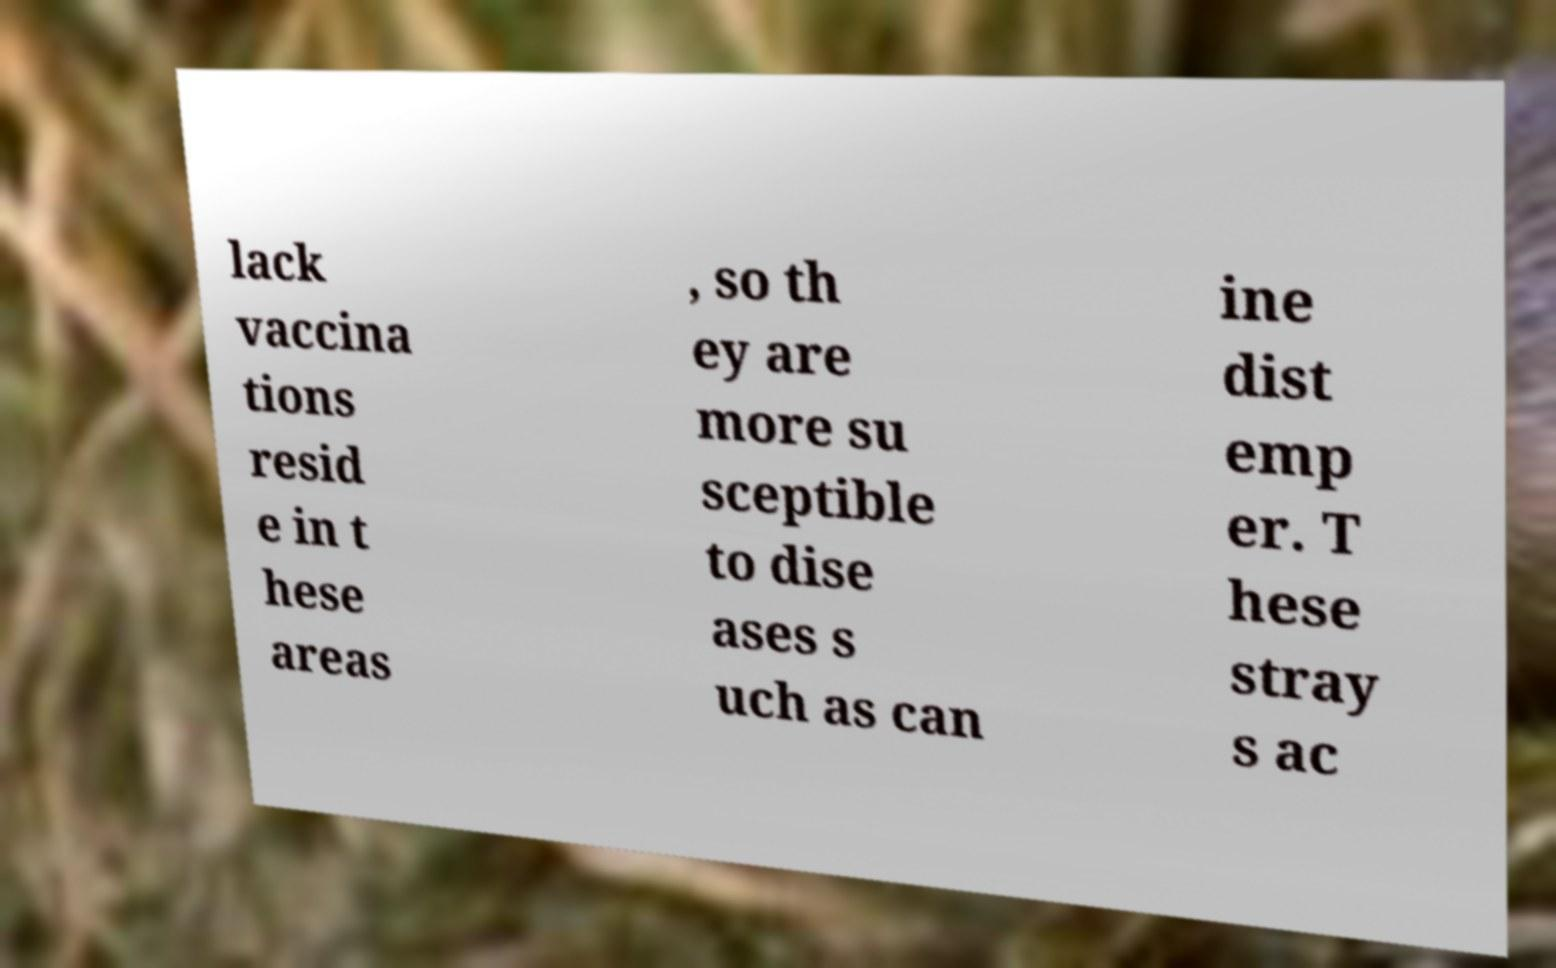Please identify and transcribe the text found in this image. lack vaccina tions resid e in t hese areas , so th ey are more su sceptible to dise ases s uch as can ine dist emp er. T hese stray s ac 